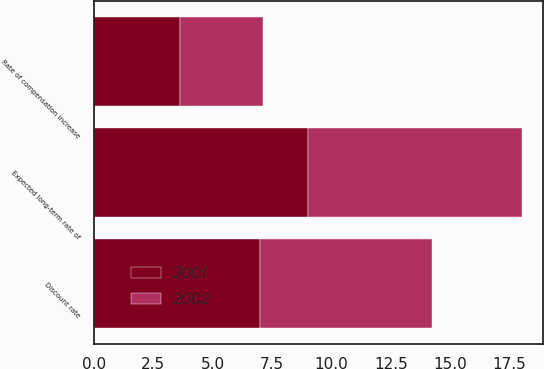Convert chart to OTSL. <chart><loc_0><loc_0><loc_500><loc_500><stacked_bar_chart><ecel><fcel>Discount rate<fcel>Rate of compensation increase<fcel>Expected long-term rate of<nl><fcel>2001<fcel>7<fcel>3.6<fcel>9<nl><fcel>2002<fcel>7.25<fcel>3.5<fcel>9<nl></chart> 